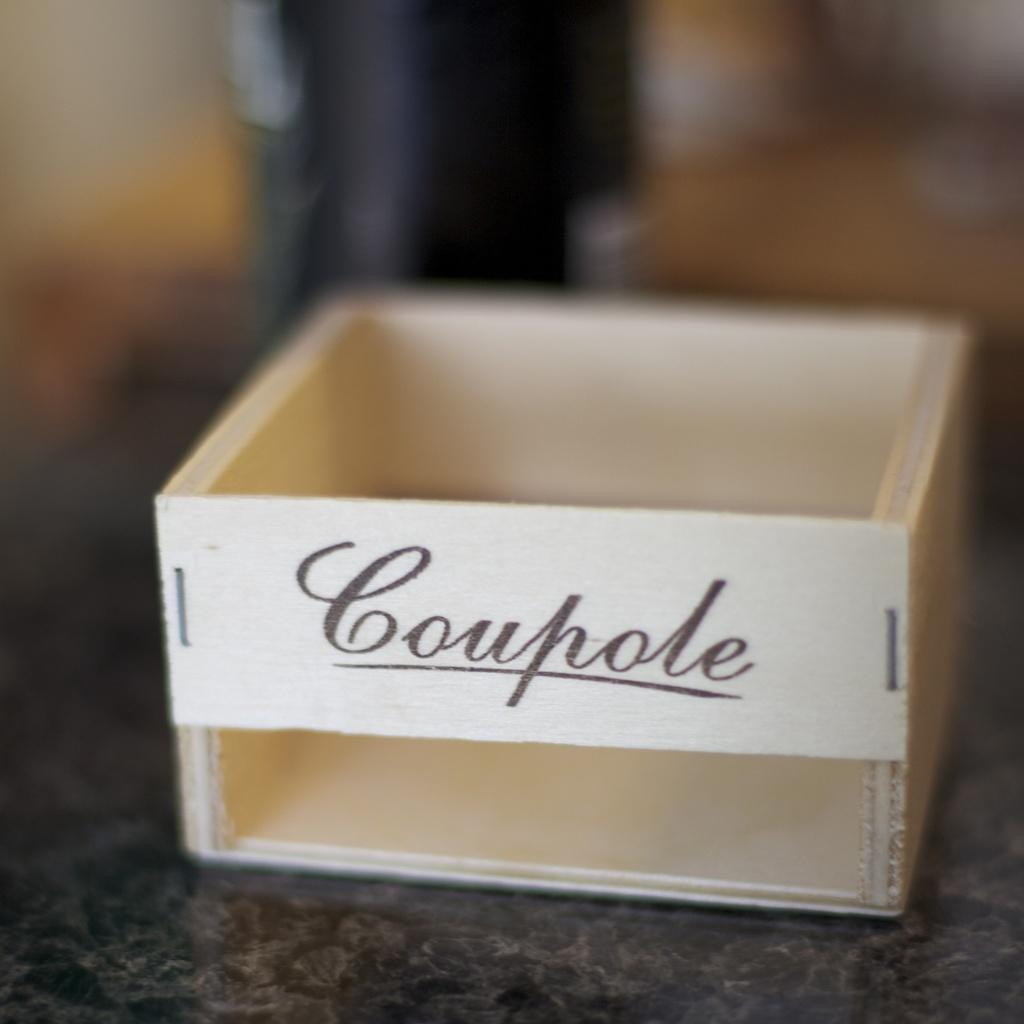How many letters are in the name?
Provide a succinct answer. 7. What is printed on the box/?
Offer a very short reply. Coupole. 